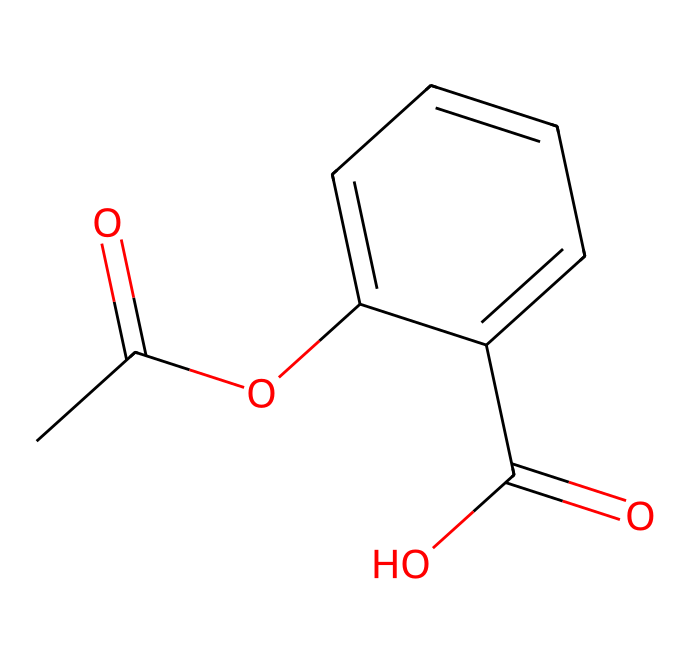What is the molecular formula of aspirin? The SMILES representation shows the number of carbon (C), hydrogen (H), and oxygen (O) atoms present in the molecule. Counting, the formula is C9H8O4.
Answer: C9H8O4 How many rings are present in the aspirin structure? By examining the SMILES, there is one cyclohexene ring indicated by "C1=CC=CC=C1" which suggests a closed loop of carbons.
Answer: 1 What type of functional groups are present in aspirin? The structure shows an ester (from the "OC" part) and a carboxylic acid (from the "C(=O)O" part) based on common functional group identifiers in organic chemistry.
Answer: ester and carboxylic acid What is the bond type between the carbonyl group and the hydroxyl group in aspirin? The carbonyl group is connected to the hydroxyl group through a single covalent bond, as seen from the "C(=O)O" structure where "C(=O)" and "O" are directly connected.
Answer: single covalent bond What is the total number of bonds in the aspirin molecule? To count the total bonds, consider each single bond and double bond in the structure. The total count of bonds is calculated as 12 from the explicit representation of all bonds in the SMILES notation.
Answer: 12 How does the presence of the carboxylic acid contribute to aspirin's effectiveness as a drug? The carboxylic acid group can donate a proton, which enhances the drug's ability to interact with biological targets such as enzymes and receptors, explaining its anti-inflammatory properties.
Answer: enhances interaction 